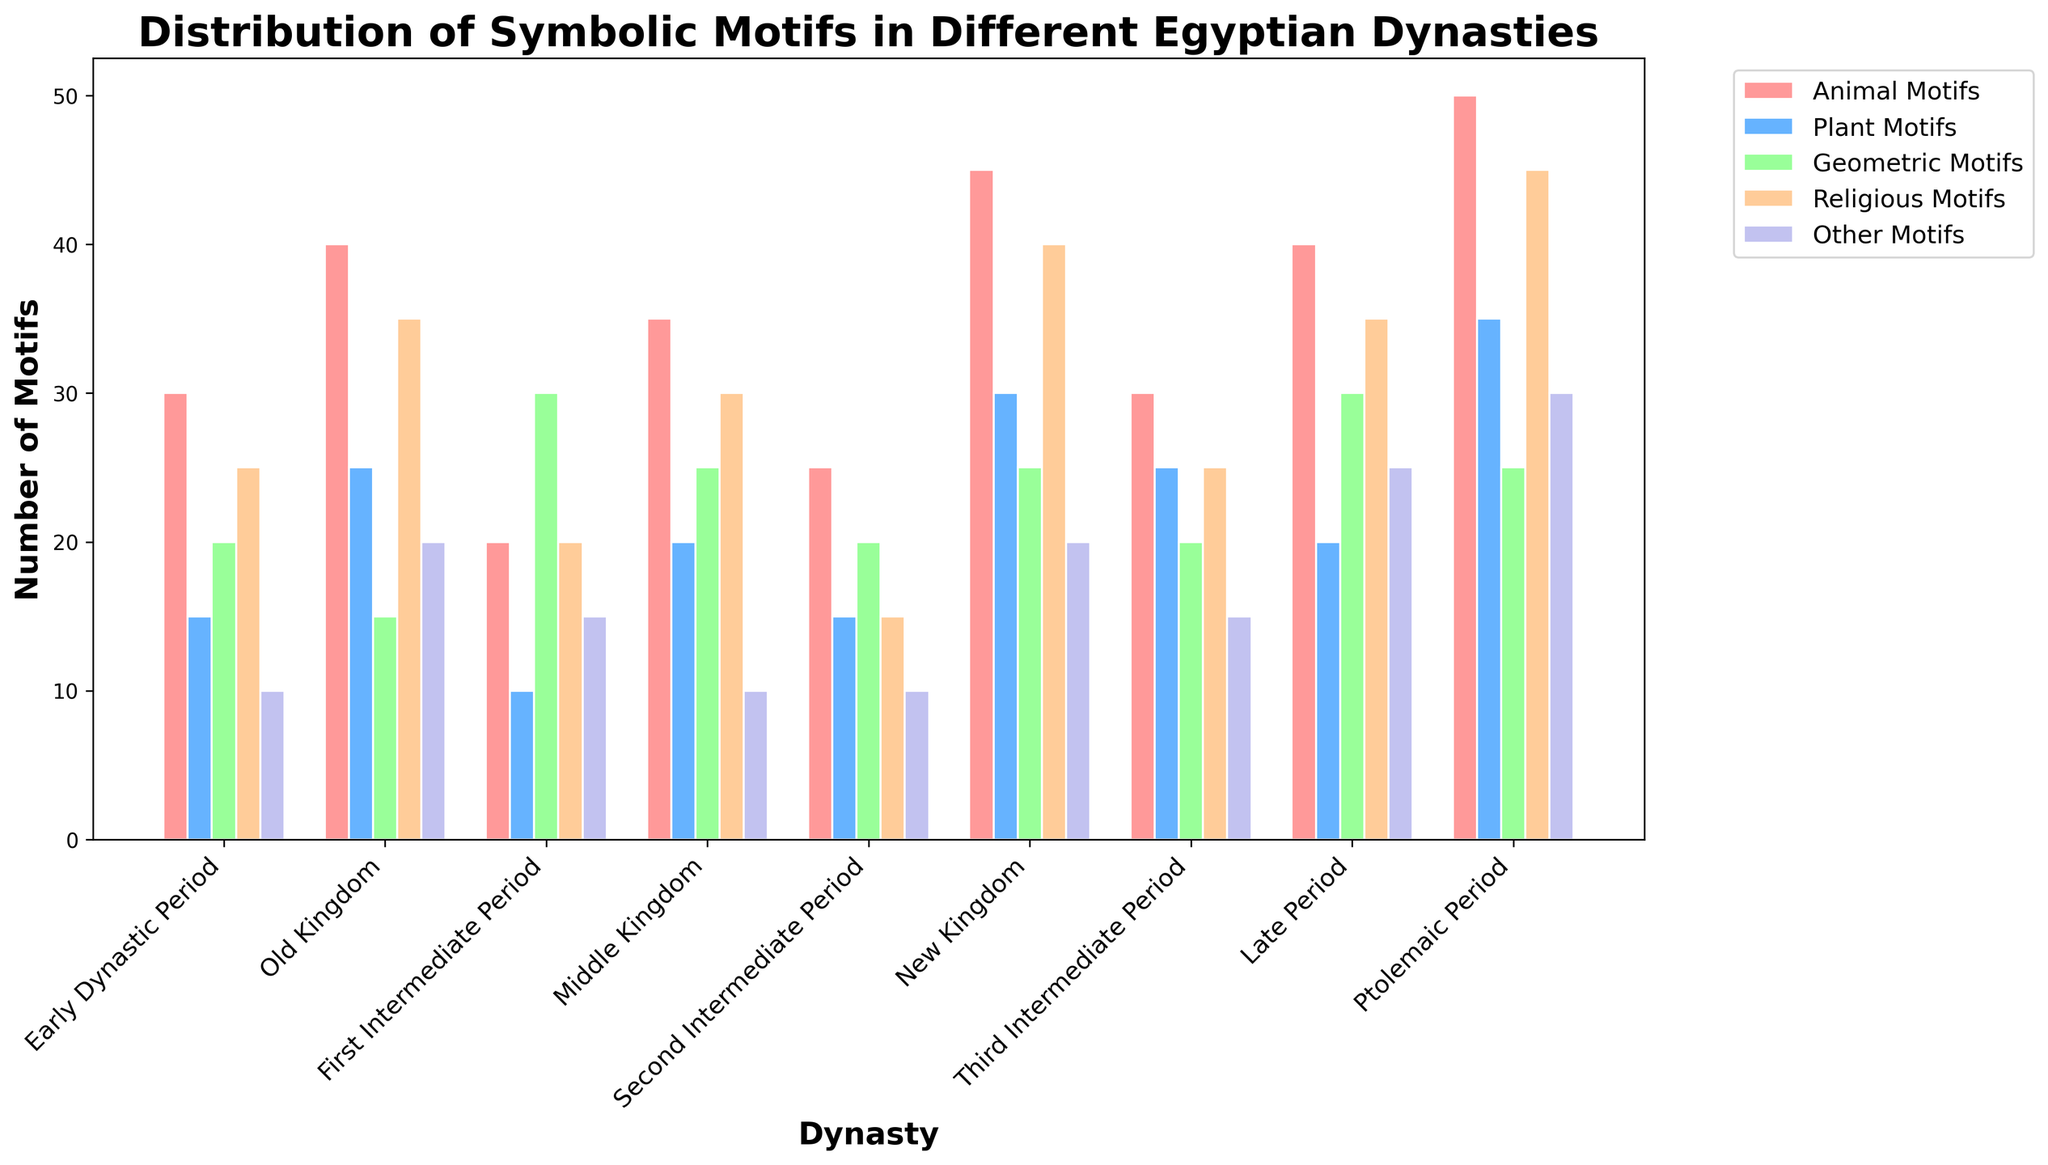What dynasty has the highest number of Animal Motifs? Look for the tallest bar in the section representing Animal Motifs. The Ptolemaic Period bar is the tallest, indicating it has the highest number.
Answer: Ptolemaic Period Which two dynasties have the same number of Plant Motifs? Identify the dynasties that have bars of equal height in the section for Plant Motifs. The Early Dynastic Period and Second Intermediate Period both have 15 Plant Motifs.
Answer: Early Dynastic Period, Second Intermediate Period What is the average number of Geometric Motifs over all dynasties? Sum the Geometric Motifs for all dynasties (20 + 15 + 30 + 25 + 20 + 25 + 20 + 30 + 25 = 210). Then, divide by the number of dynasties (210/9).
Answer: 23.33 Which dynasty has more Religious Motifs: Old Kingdom or Late Period? Compare the height of the bars in the Religious Motifs section for Old Kingdom (35) and Late Period (35), both are equal.
Answer: Both What is the total number of Other Motifs across all dynasties? Sum the numbers of Other Motifs for each dynasty (10 + 20 + 15 + 10 + 10 + 20 + 15 + 25 + 30 = 155).
Answer: 155 Which motif type has the least representation in the First Intermediate Period? Identify the shortest bar in the First Intermediate Period section. The Plant Motifs bar is the shortest, indicating it has the least representation (10).
Answer: Plant Motifs How does the number of Animal Motifs in the New Kingdom compare to the Third Intermediate Period? Compare the height of the bars in the Animal Motifs section for New Kingdom (45) and Third Intermediate Period (30).
Answer: New Kingdom has more What's the difference in the number of Religious Motifs between the New Kingdom and the Second Intermediate Period? Subtract the number of Religious Motifs in the Second Intermediate Period from the number in the New Kingdom (40 - 15 = 25).
Answer: 25 Which motif type shows the most significant increase from the Early Dynastic Period to the Ptolemaic Period? For each motif type, subtract the number in the Early Dynastic Period from the number in the Ptolemaic Period. The largest increase is in Religious Motifs (45 - 25 = 20).
Answer: Religious Motifs 